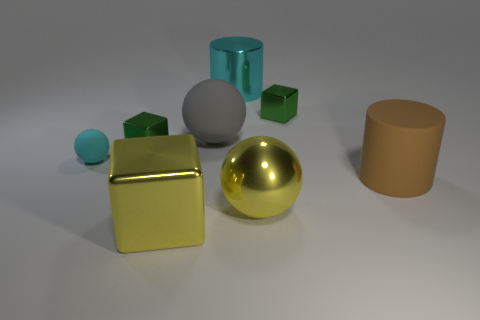Describe the lighting of the scene. The scene is lit in a manner that casts soft shadows and gives a sense of diffused lighting. There is no harsh direct light, but rather a gentle illumination that highlights the three-dimensionality of the objects and their colors without creating overly deep shadows or bright glares. 